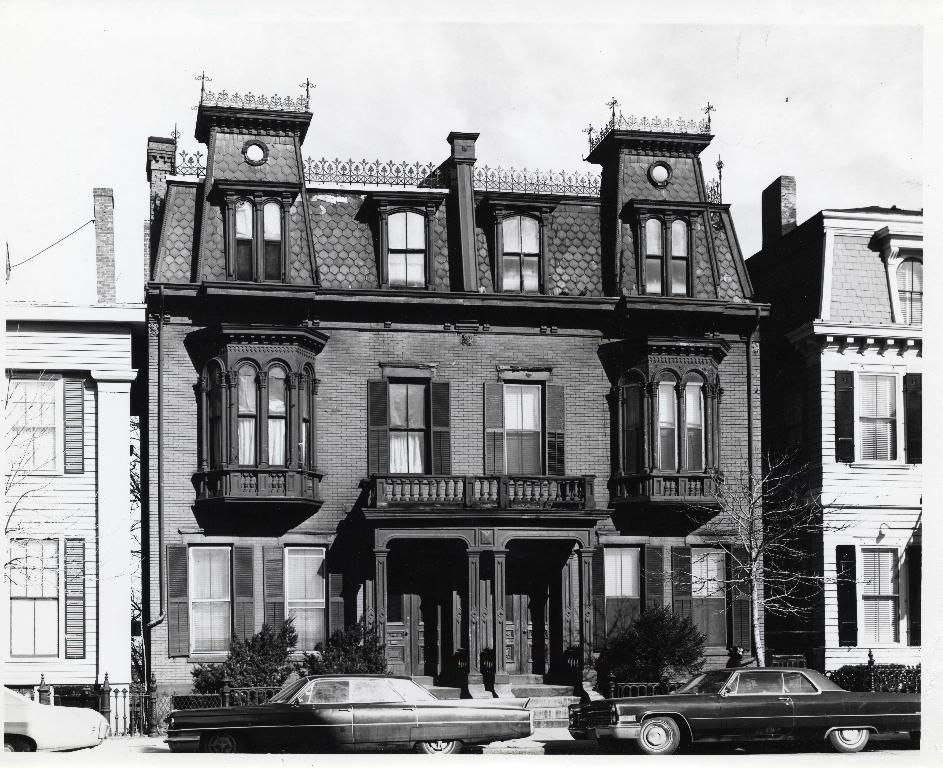What type of structures are present in the image? There are buildings in the image. What else can be seen in the image besides the buildings? There are cars in the image. What features do the buildings have? The buildings have doors and windows. What is located beside the car in the image? There are plants beside the car. What is visible at the top of the image? The sky is visible at the top of the image. How many apples are hanging from the button in the image? There is no button or apples present in the image. What type of bird can be seen perched on the wren in the image? There is no wren or bird present in the image. 